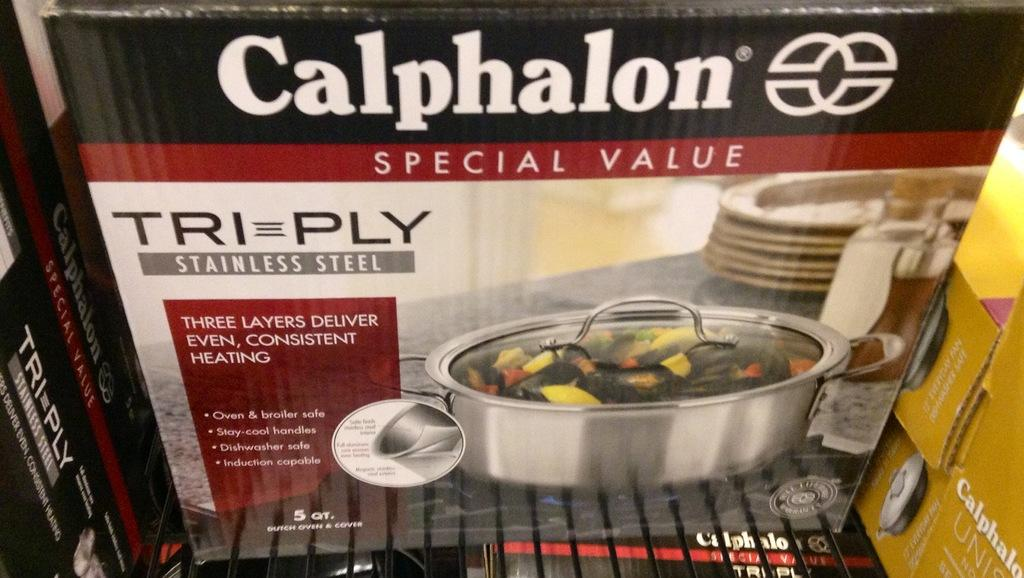What types of objects are depicted in the pictures within the image? There are pictures of bowls and plates in the image. Are there any other objects shown in the pictures within the image? Yes, there is a picture of a bottle in the image. What is written on the carton boxes in the image? There is text written on the carton boxes in the image. What type of string is being used to hold up the trousers in the image? There are no trousers or string present in the image; it only contains pictures of bowls, plates, a bottle, and text on carton boxes. 